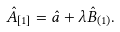Convert formula to latex. <formula><loc_0><loc_0><loc_500><loc_500>\hat { A } _ { [ 1 ] } = \hat { a } + \lambda \hat { B } _ { ( 1 ) } .</formula> 